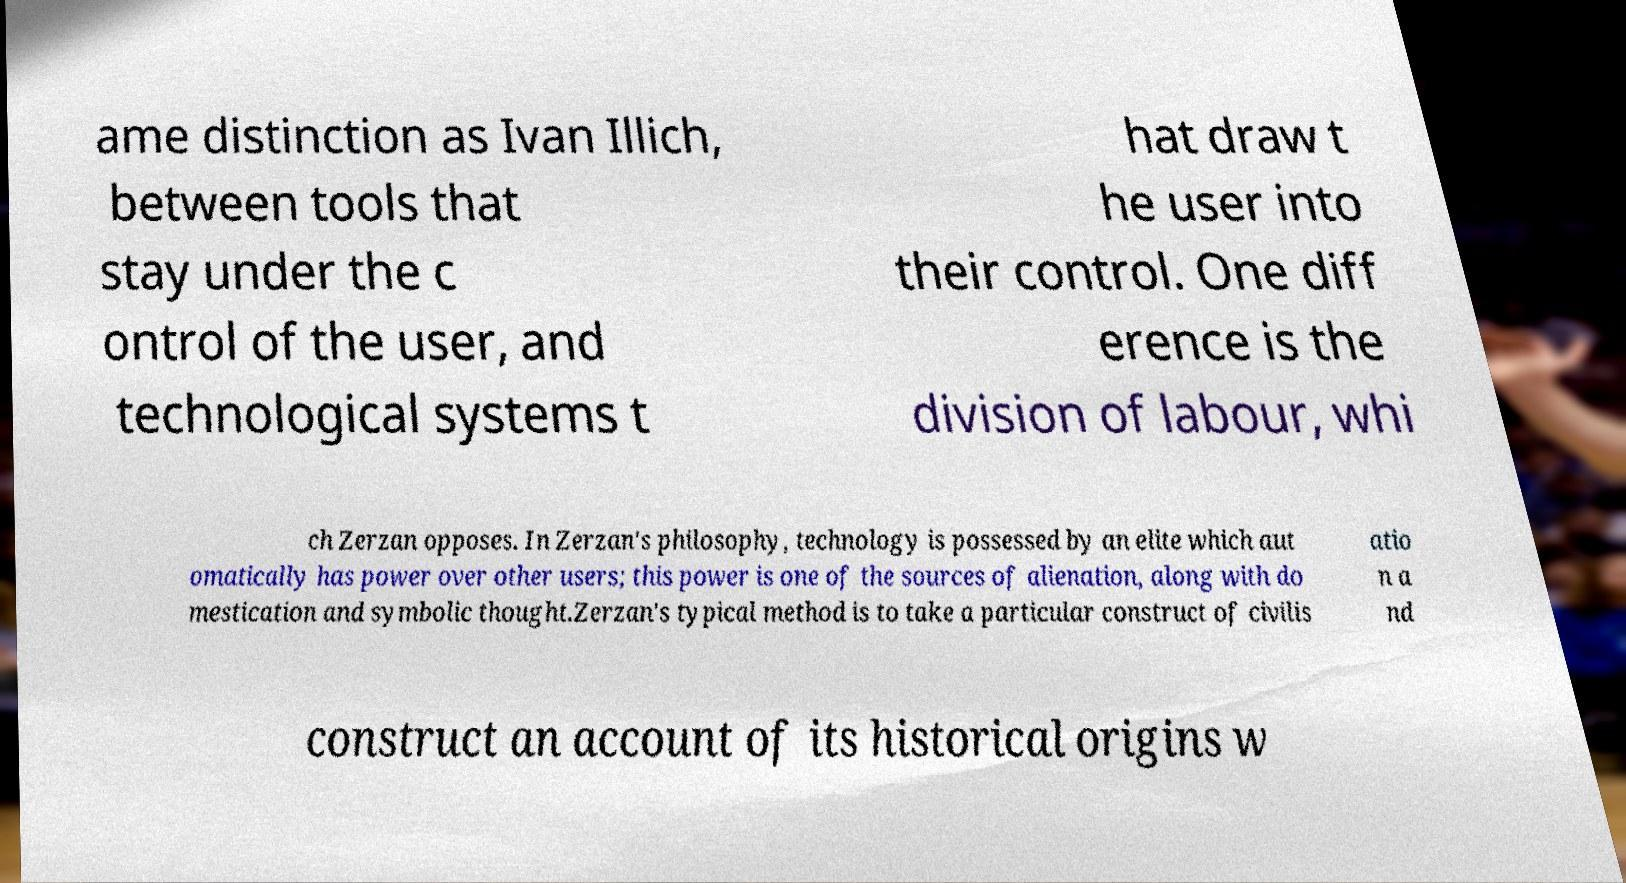Could you extract and type out the text from this image? ame distinction as Ivan Illich, between tools that stay under the c ontrol of the user, and technological systems t hat draw t he user into their control. One diff erence is the division of labour, whi ch Zerzan opposes. In Zerzan's philosophy, technology is possessed by an elite which aut omatically has power over other users; this power is one of the sources of alienation, along with do mestication and symbolic thought.Zerzan's typical method is to take a particular construct of civilis atio n a nd construct an account of its historical origins w 